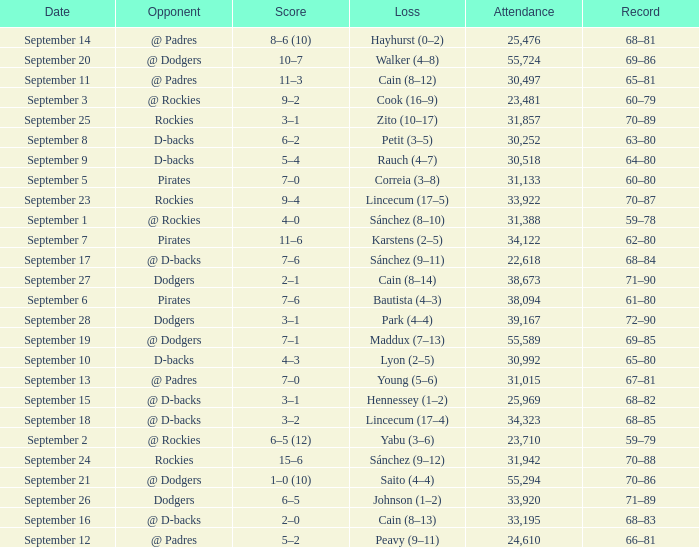What was the attendance on September 28? 39167.0. 